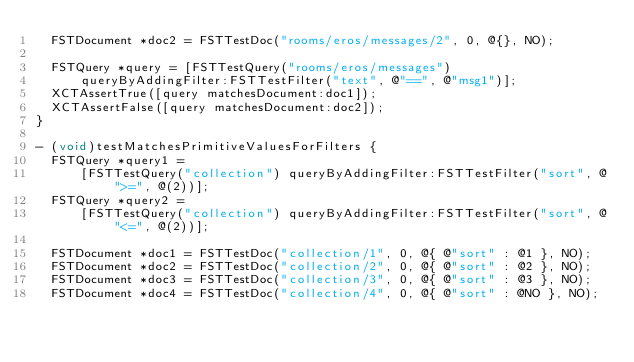Convert code to text. <code><loc_0><loc_0><loc_500><loc_500><_ObjectiveC_>  FSTDocument *doc2 = FSTTestDoc("rooms/eros/messages/2", 0, @{}, NO);

  FSTQuery *query = [FSTTestQuery("rooms/eros/messages")
      queryByAddingFilter:FSTTestFilter("text", @"==", @"msg1")];
  XCTAssertTrue([query matchesDocument:doc1]);
  XCTAssertFalse([query matchesDocument:doc2]);
}

- (void)testMatchesPrimitiveValuesForFilters {
  FSTQuery *query1 =
      [FSTTestQuery("collection") queryByAddingFilter:FSTTestFilter("sort", @">=", @(2))];
  FSTQuery *query2 =
      [FSTTestQuery("collection") queryByAddingFilter:FSTTestFilter("sort", @"<=", @(2))];

  FSTDocument *doc1 = FSTTestDoc("collection/1", 0, @{ @"sort" : @1 }, NO);
  FSTDocument *doc2 = FSTTestDoc("collection/2", 0, @{ @"sort" : @2 }, NO);
  FSTDocument *doc3 = FSTTestDoc("collection/3", 0, @{ @"sort" : @3 }, NO);
  FSTDocument *doc4 = FSTTestDoc("collection/4", 0, @{ @"sort" : @NO }, NO);</code> 